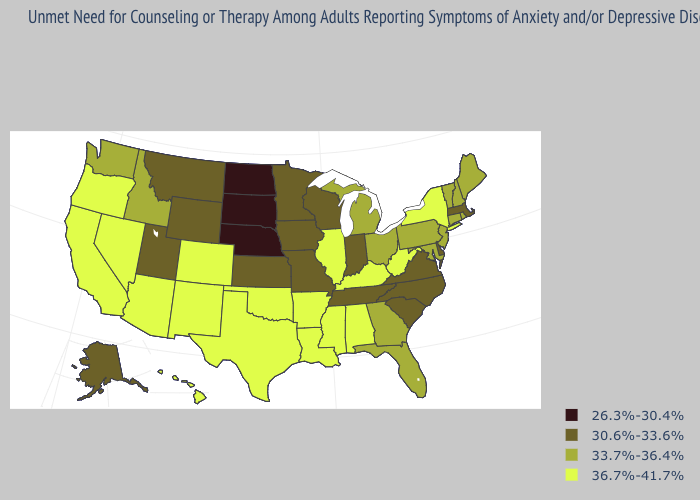Name the states that have a value in the range 30.6%-33.6%?
Be succinct. Alaska, Delaware, Indiana, Iowa, Kansas, Massachusetts, Minnesota, Missouri, Montana, North Carolina, South Carolina, Tennessee, Utah, Virginia, Wisconsin, Wyoming. Does New York have a higher value than Iowa?
Be succinct. Yes. Does Indiana have a lower value than Massachusetts?
Be succinct. No. Name the states that have a value in the range 36.7%-41.7%?
Give a very brief answer. Alabama, Arizona, Arkansas, California, Colorado, Hawaii, Illinois, Kentucky, Louisiana, Mississippi, Nevada, New Mexico, New York, Oklahoma, Oregon, Texas, West Virginia. What is the value of Illinois?
Short answer required. 36.7%-41.7%. What is the highest value in states that border Oklahoma?
Give a very brief answer. 36.7%-41.7%. Name the states that have a value in the range 36.7%-41.7%?
Concise answer only. Alabama, Arizona, Arkansas, California, Colorado, Hawaii, Illinois, Kentucky, Louisiana, Mississippi, Nevada, New Mexico, New York, Oklahoma, Oregon, Texas, West Virginia. Which states have the lowest value in the West?
Answer briefly. Alaska, Montana, Utah, Wyoming. What is the highest value in states that border Maine?
Be succinct. 33.7%-36.4%. What is the highest value in states that border Maryland?
Answer briefly. 36.7%-41.7%. Which states hav the highest value in the West?
Write a very short answer. Arizona, California, Colorado, Hawaii, Nevada, New Mexico, Oregon. Name the states that have a value in the range 26.3%-30.4%?
Be succinct. Nebraska, North Dakota, South Dakota. Does Connecticut have the same value as Vermont?
Quick response, please. Yes. Is the legend a continuous bar?
Keep it brief. No. Name the states that have a value in the range 36.7%-41.7%?
Give a very brief answer. Alabama, Arizona, Arkansas, California, Colorado, Hawaii, Illinois, Kentucky, Louisiana, Mississippi, Nevada, New Mexico, New York, Oklahoma, Oregon, Texas, West Virginia. 